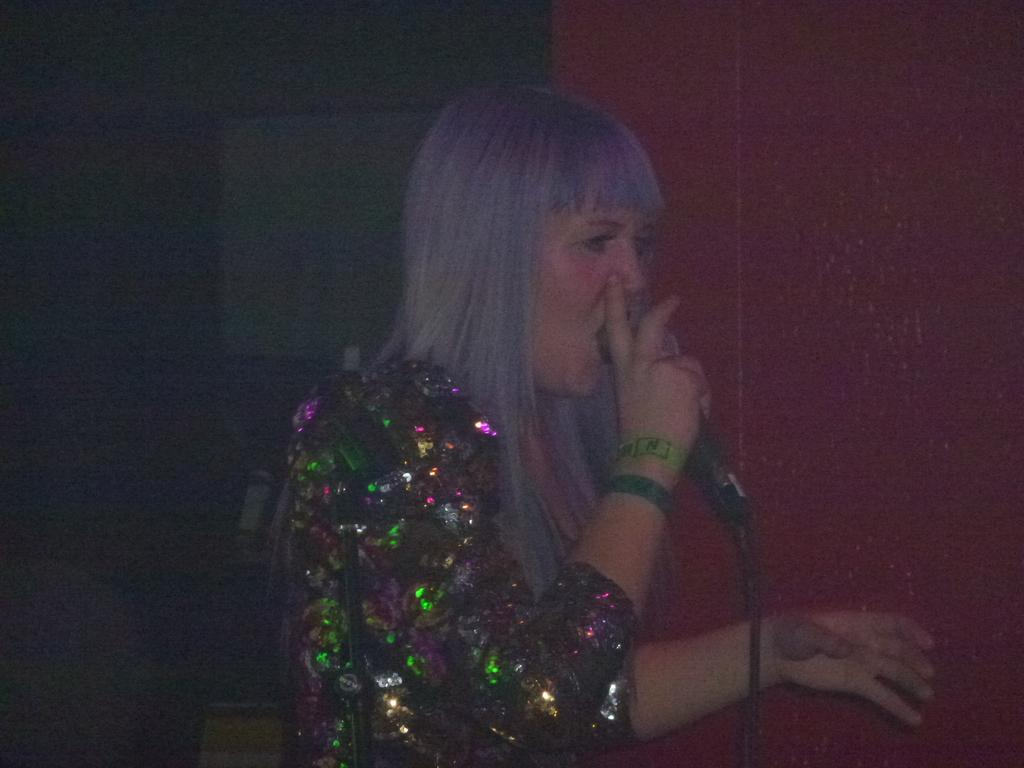What is the main subject of the image? There is a woman in the image. What is the woman doing in the image? The woman is singing a song. What is the woman wearing in the image? The woman is wearing a sequin dress. What can be seen behind the woman in the image? There is a red surface behind the woman. What type of scent is emanating from the faucet in the image? There is no faucet present in the image, so it is not possible to determine the scent emanating from it. 